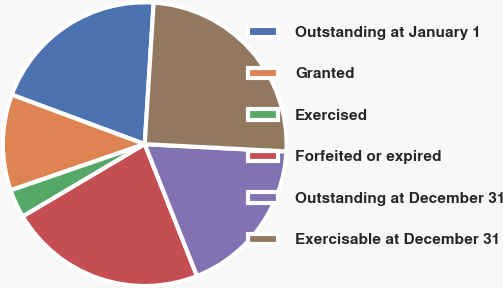<chart> <loc_0><loc_0><loc_500><loc_500><pie_chart><fcel>Outstanding at January 1<fcel>Granted<fcel>Exercised<fcel>Forfeited or expired<fcel>Outstanding at December 31<fcel>Exercisable at December 31<nl><fcel>20.34%<fcel>10.94%<fcel>3.24%<fcel>22.49%<fcel>18.18%<fcel>24.81%<nl></chart> 